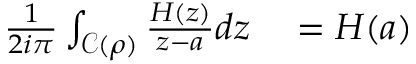Convert formula to latex. <formula><loc_0><loc_0><loc_500><loc_500>\begin{array} { r } { \begin{array} { r l } { \frac { 1 } { 2 i \pi } \int _ { \mathcal { C } ( \rho ) } \frac { H ( z ) } { z - a } d z } & = H ( a ) } \end{array} } \end{array}</formula> 